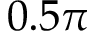Convert formula to latex. <formula><loc_0><loc_0><loc_500><loc_500>0 . 5 \pi</formula> 